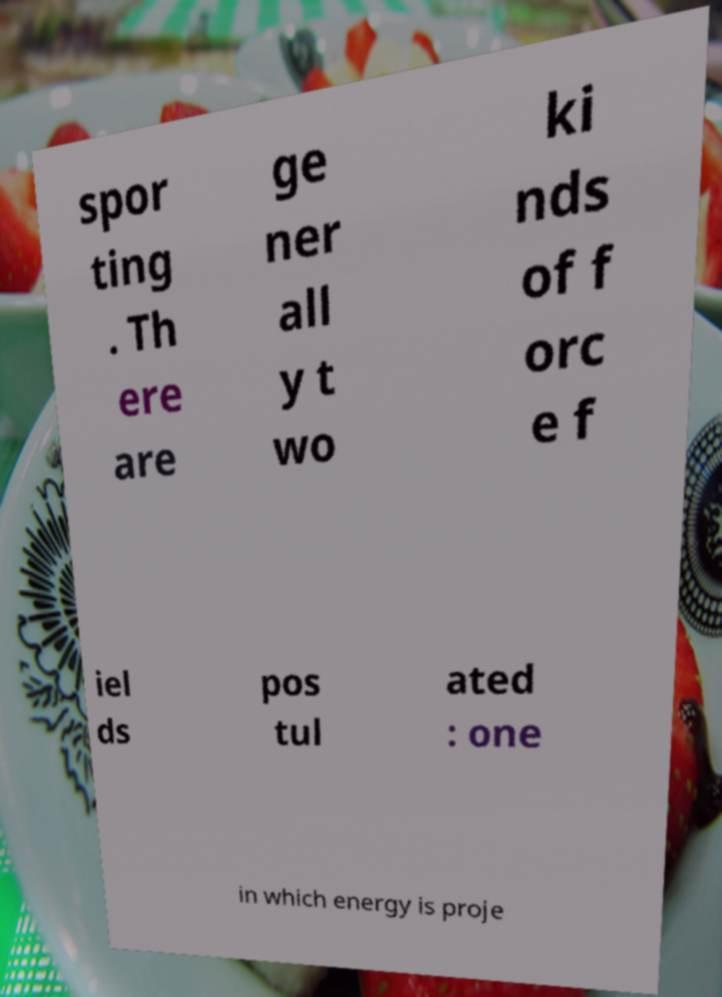I need the written content from this picture converted into text. Can you do that? spor ting . Th ere are ge ner all y t wo ki nds of f orc e f iel ds pos tul ated : one in which energy is proje 